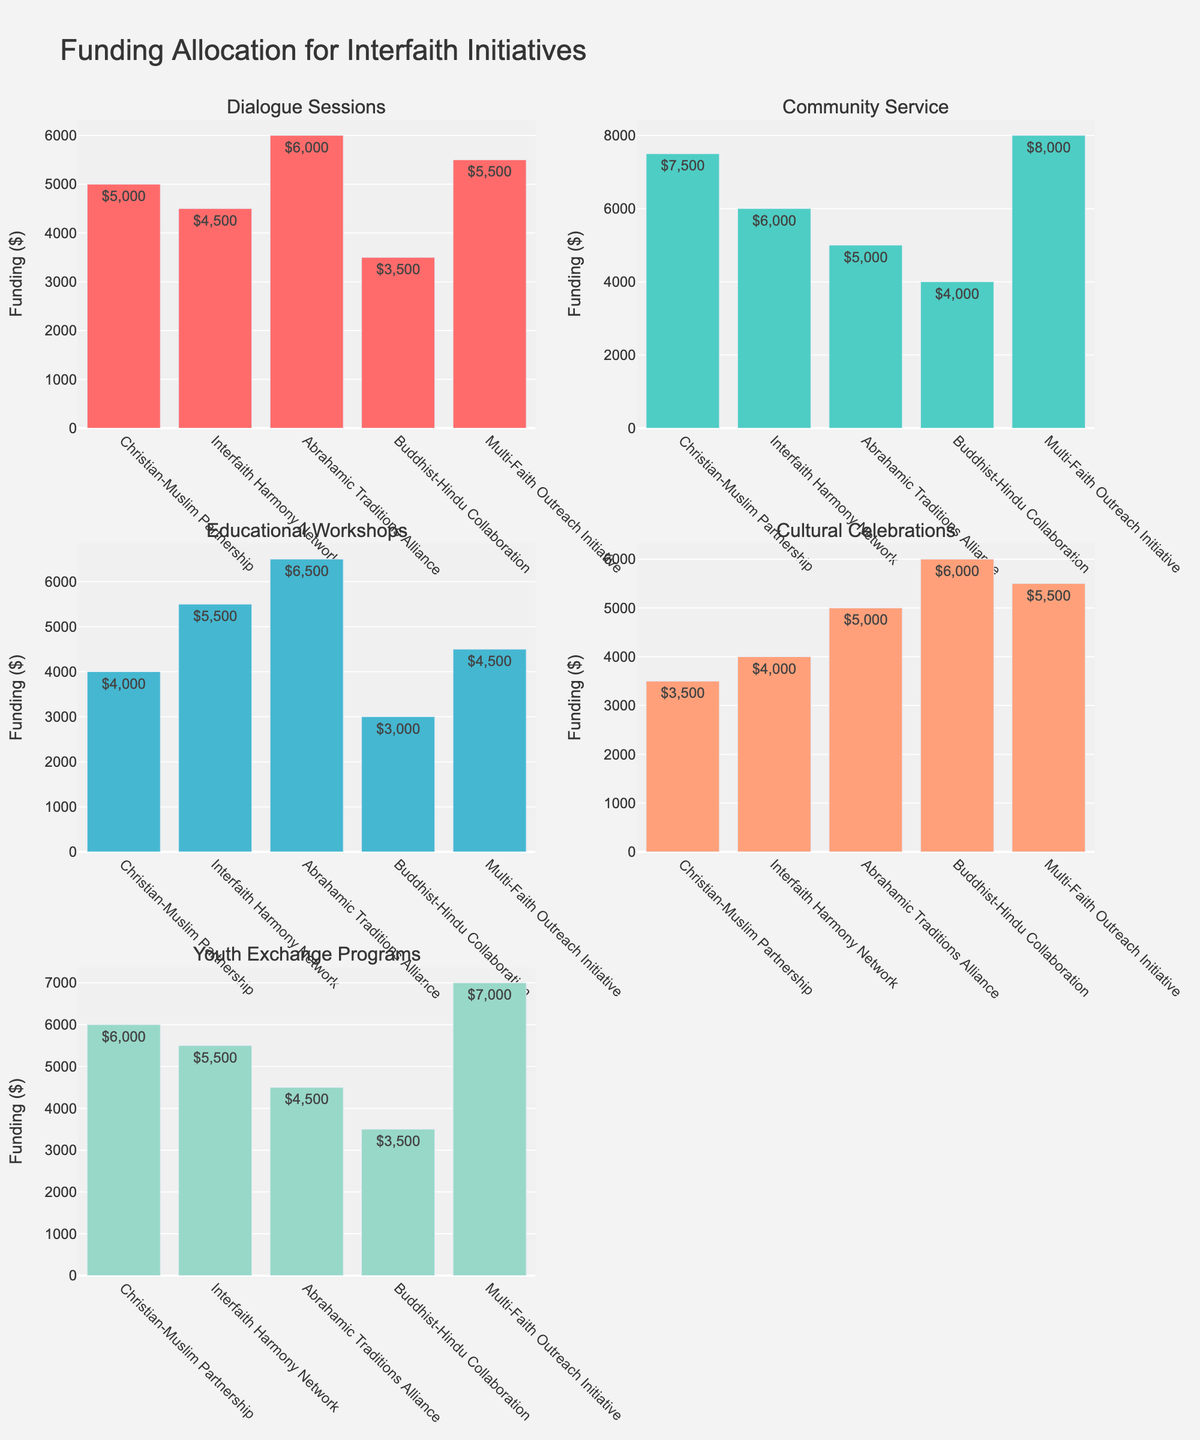What's the title of the figure? The title of the figure is usually placed at the top of the chart and is easily readable.
Answer: Funding Allocation for Interfaith Initiatives How much funding is allocated to Dialogue Sessions under the Christian-Muslim Partnership program? Look at the subplot for Dialogue Sessions and find the bar corresponding to the Christian-Muslim Partnership. The text on the bar shows the amount.
Answer: $5000 Which program received the highest funding for Community Service? Examine the Community Service subplot and compare the heights of the bars. The Multi-Faith Outreach Initiative has the tallest bar.
Answer: Multi-Faith Outreach Initiative What is the total funding received by the Interfaith Harmony Network across all categories? Sum the funding amounts for Dialogue Sessions ($4500), Community Service ($6000), Educational Workshops ($5500), Cultural Celebrations ($4000), and Youth Exchange Programs ($5500).
Answer: $25500 Between the Cultural Celebrations category and the Youth Exchange Programs category, which has higher average funding across all programs? Calculate the total funding for each category and then find the average by dividing by the number of programs (5). For Cultural Celebrations: ($3500 + $4000 + $5000 + $6000 + $5500) = $8000/$5000/$2500/$3000/$4500 respectively. For Youth Exchange Programs: ($6000 + $5500 + $4500 + $3500 + $7000). The total for Cultural Celebrations is $31000, and for Youth Exchange Programs is $26500. The average funding for Cultural Celebrations is higher.
Answer: Cultural Celebrations What is the combined funding for Dialogue Sessions for the Abrahamic Traditions Alliance and Buddha-Hindu Collaboration programs? To get the combined funding, add the amount allocated in both programs for Dialogue Sessions. For Abrahamic Traditions Alliance, it's $6000 and for Buddha-Hindu Collaboration, it's $3500.
Answer: $9500 Which program has the lowest funding for Educational Workshops? Examine the Educational Workshops subplot and compare the heights of the bars. The Buddha-Hindu Collaboration has the shortest bar.
Answer: Buddha-Hindu Collaboration How much more funding does the Multi-Faith Outreach Initiative receive for Community Service compared to Dialogue Sessions? Subtract the funding for Dialogue Sessions from the funding for Community Service for the Multi-Faith Outreach Initiative. Community Service is $8000 and Dialogue Sessions is $5500.
Answer: $2500 